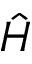Convert formula to latex. <formula><loc_0><loc_0><loc_500><loc_500>\hat { H }</formula> 